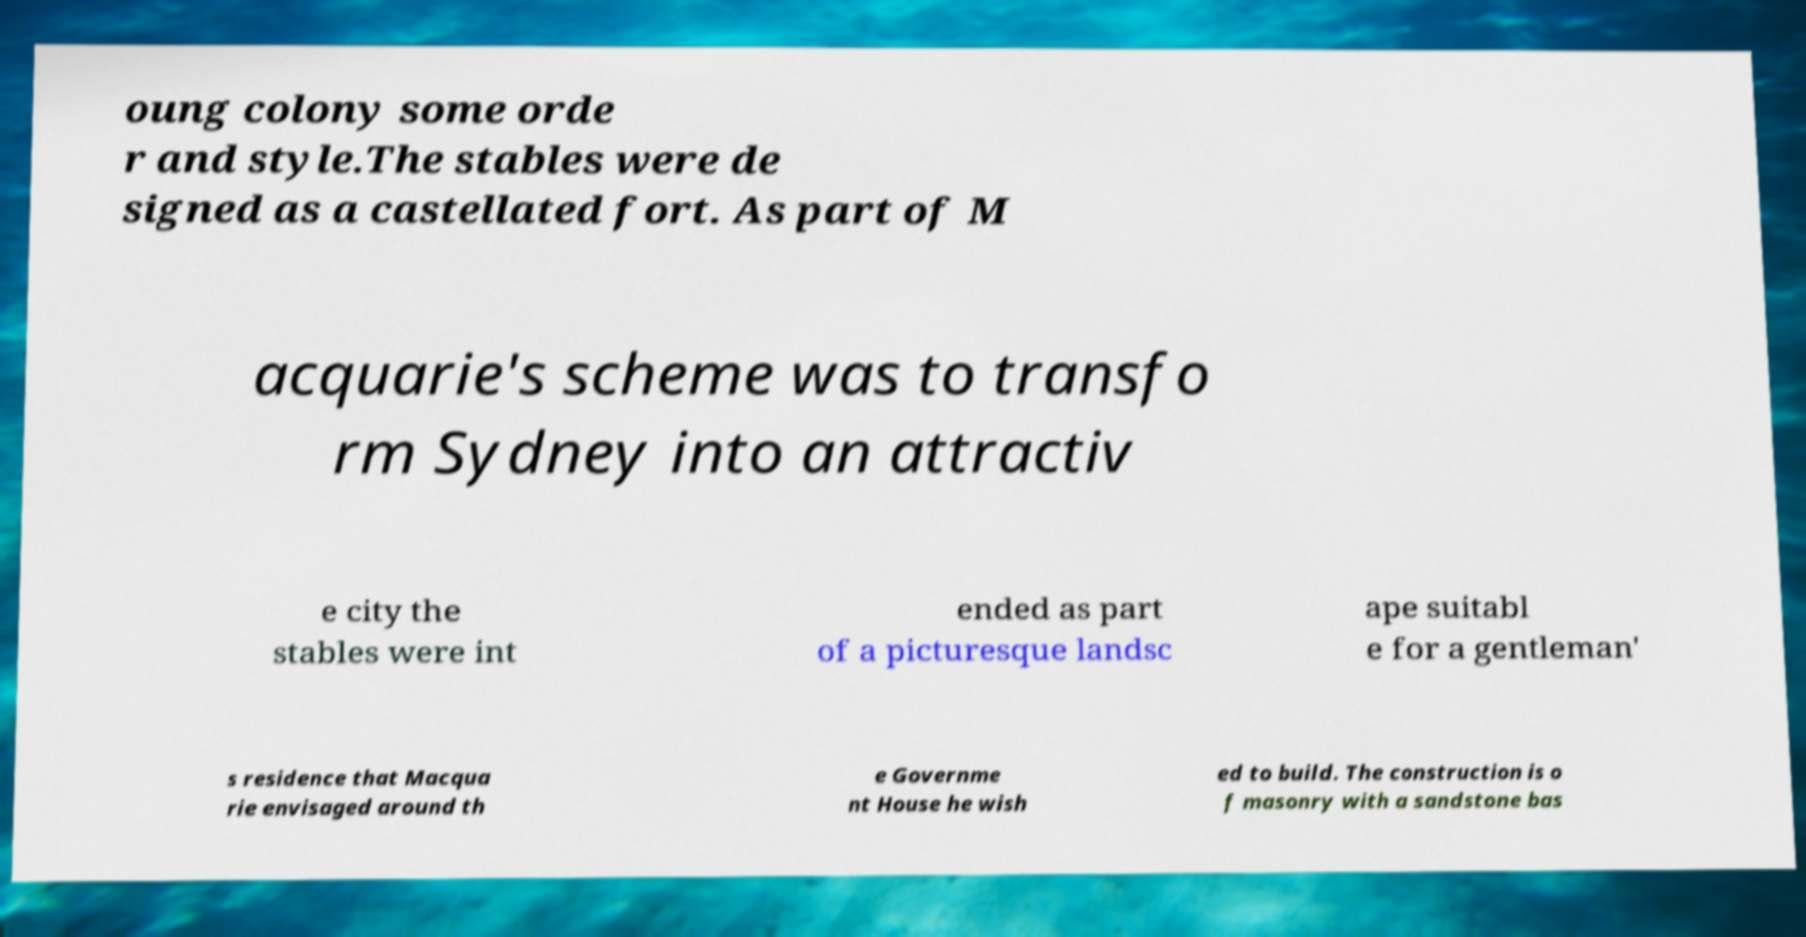There's text embedded in this image that I need extracted. Can you transcribe it verbatim? oung colony some orde r and style.The stables were de signed as a castellated fort. As part of M acquarie's scheme was to transfo rm Sydney into an attractiv e city the stables were int ended as part of a picturesque landsc ape suitabl e for a gentleman' s residence that Macqua rie envisaged around th e Governme nt House he wish ed to build. The construction is o f masonry with a sandstone bas 